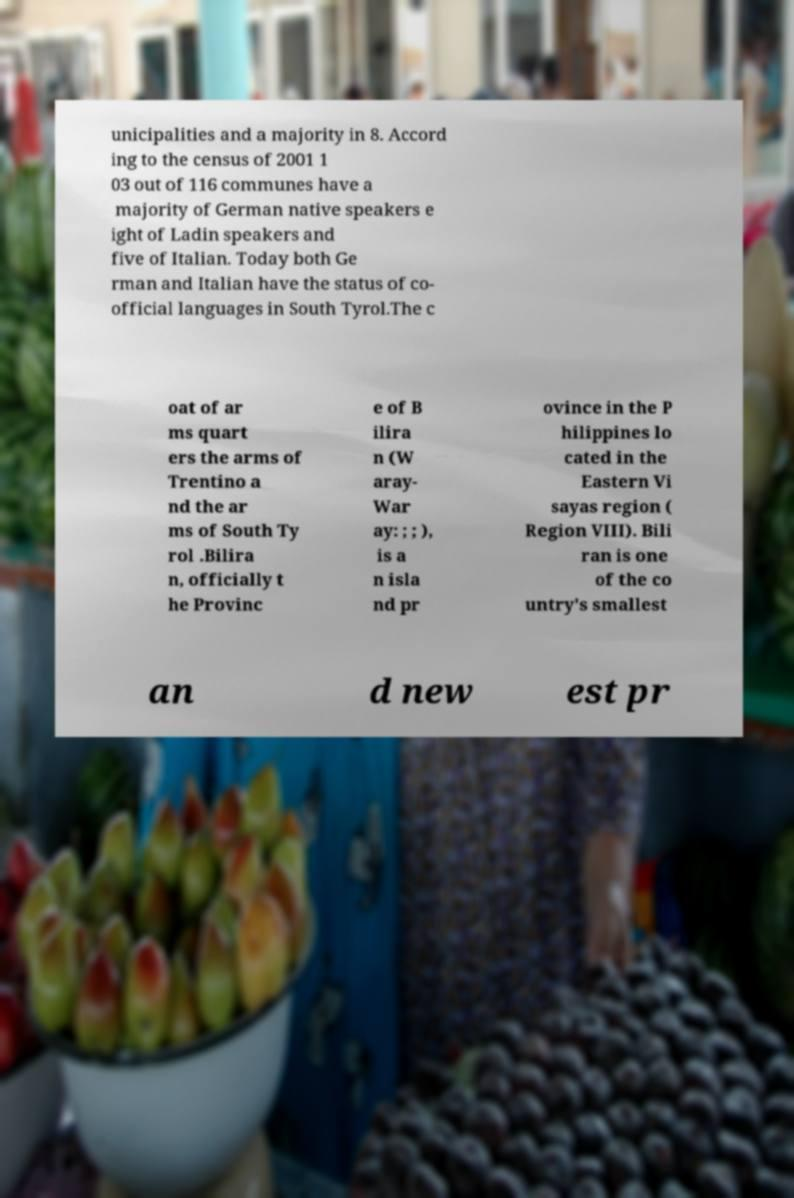Can you read and provide the text displayed in the image?This photo seems to have some interesting text. Can you extract and type it out for me? unicipalities and a majority in 8. Accord ing to the census of 2001 1 03 out of 116 communes have a majority of German native speakers e ight of Ladin speakers and five of Italian. Today both Ge rman and Italian have the status of co- official languages in South Tyrol.The c oat of ar ms quart ers the arms of Trentino a nd the ar ms of South Ty rol .Bilira n, officially t he Provinc e of B ilira n (W aray- War ay: ; ; ), is a n isla nd pr ovince in the P hilippines lo cated in the Eastern Vi sayas region ( Region VIII). Bili ran is one of the co untry's smallest an d new est pr 